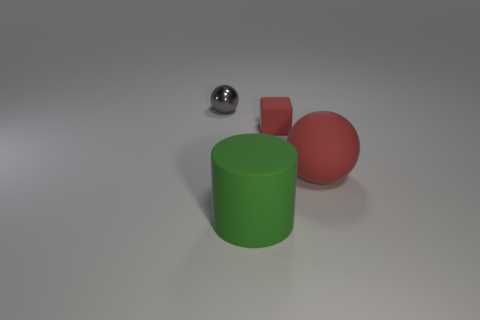Do the tiny object that is in front of the tiny gray metallic sphere and the sphere that is to the right of the shiny thing have the same color?
Offer a very short reply. Yes. Are there any other things that are the same material as the tiny ball?
Provide a succinct answer. No. There is another thing that is the same shape as the gray shiny object; what size is it?
Provide a succinct answer. Large. What material is the gray thing?
Offer a terse response. Metal. What is the size of the ball that is the same color as the small rubber thing?
Your answer should be very brief. Large. There is a large rubber object on the right side of the big green cylinder; is its shape the same as the metallic thing?
Offer a terse response. Yes. What is the ball that is to the right of the big cylinder made of?
Your answer should be compact. Rubber. What is the shape of the other thing that is the same color as the small rubber object?
Provide a succinct answer. Sphere. Is there another small gray sphere that has the same material as the gray sphere?
Ensure brevity in your answer.  No. What size is the shiny ball?
Your response must be concise. Small. 